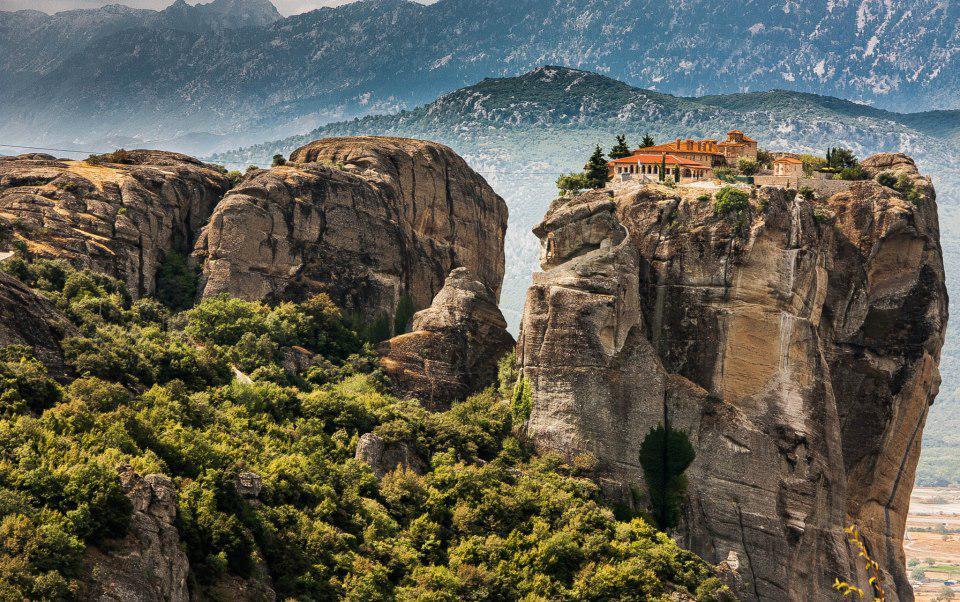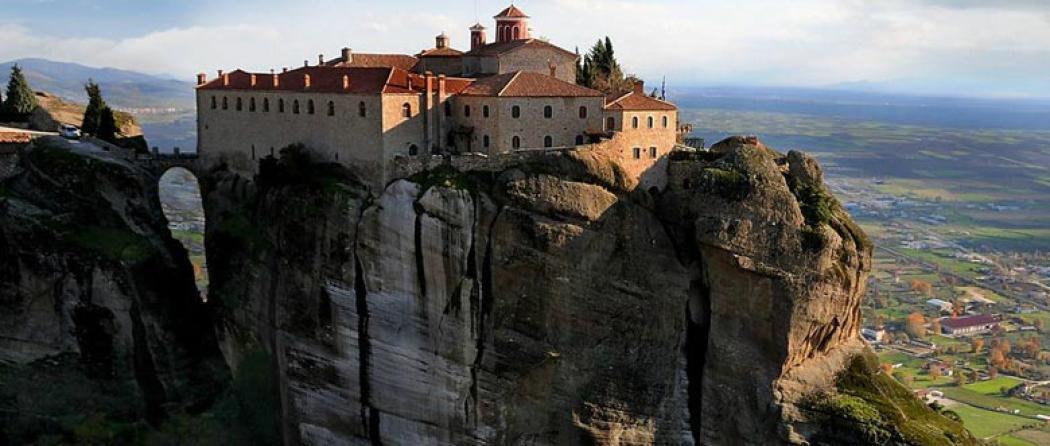The first image is the image on the left, the second image is the image on the right. For the images displayed, is the sentence "One image has misty clouds in between mountains." factually correct? Answer yes or no. Yes. 